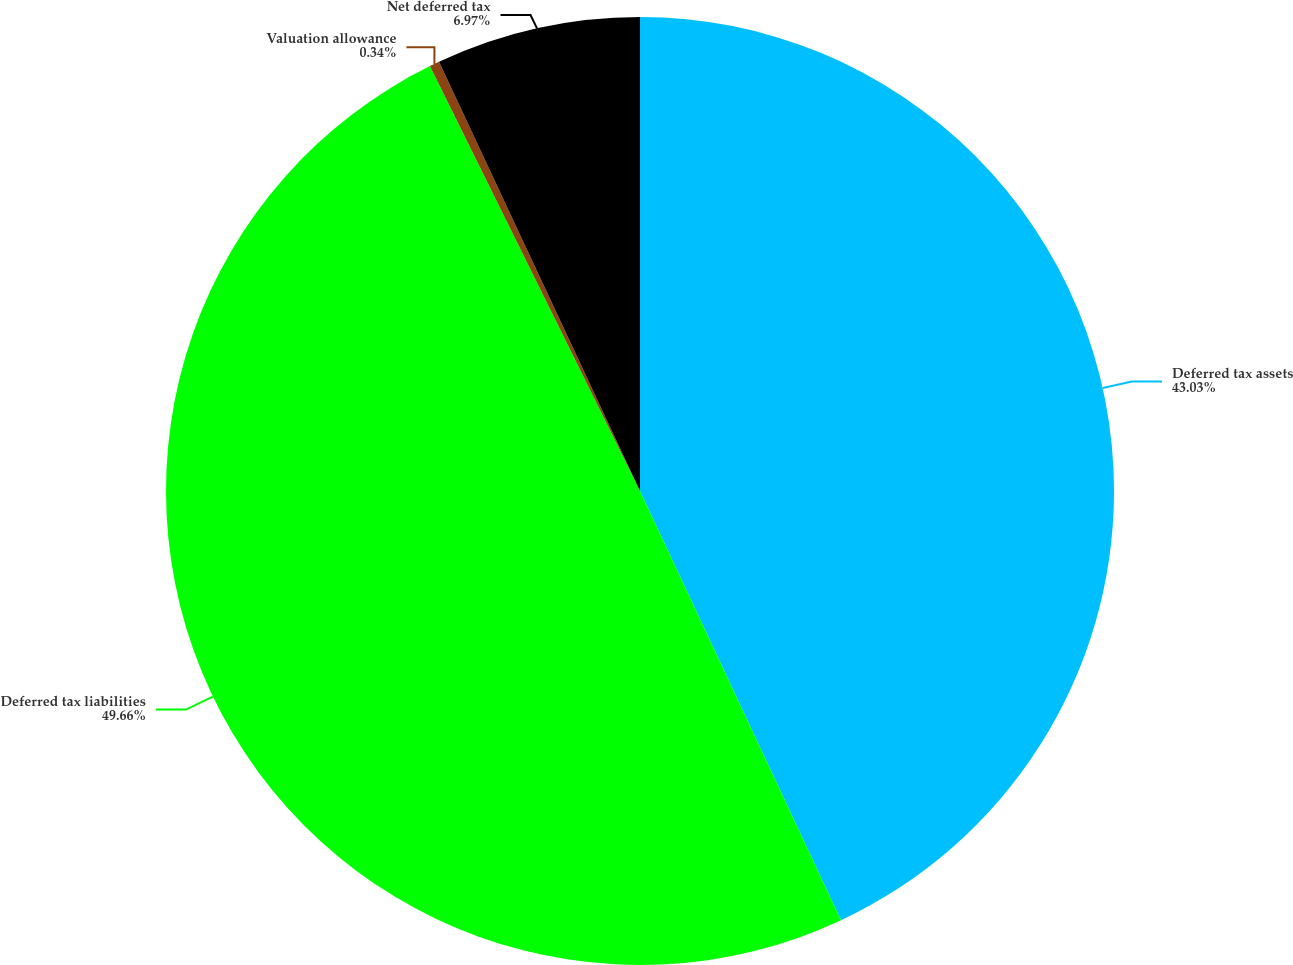Convert chart to OTSL. <chart><loc_0><loc_0><loc_500><loc_500><pie_chart><fcel>Deferred tax assets<fcel>Deferred tax liabilities<fcel>Valuation allowance<fcel>Net deferred tax<nl><fcel>43.03%<fcel>49.66%<fcel>0.34%<fcel>6.97%<nl></chart> 